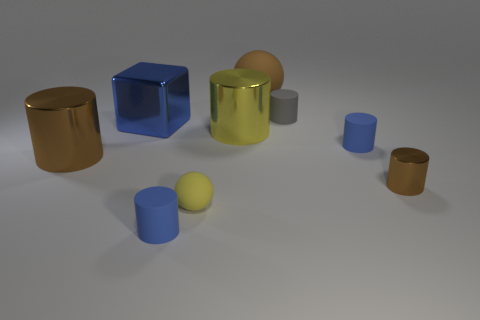What is the big brown thing on the left side of the big yellow object made of?
Provide a succinct answer. Metal. There is a block that is the same material as the large yellow thing; what color is it?
Provide a short and direct response. Blue. What number of rubber objects are blue blocks or tiny brown cylinders?
Keep it short and to the point. 0. What is the shape of the yellow shiny thing that is the same size as the blue shiny thing?
Keep it short and to the point. Cylinder. What number of objects are tiny blue rubber cylinders that are right of the brown ball or tiny matte cylinders behind the big blue cube?
Your response must be concise. 2. What is the material of the blue cube that is the same size as the yellow cylinder?
Make the answer very short. Metal. How many other things are there of the same material as the gray cylinder?
Offer a terse response. 4. Are there the same number of objects that are to the left of the shiny block and large matte objects right of the gray object?
Give a very brief answer. No. What number of brown objects are small matte objects or rubber cylinders?
Offer a terse response. 0. There is a small ball; is it the same color as the big metallic thing on the right side of the big blue object?
Provide a short and direct response. Yes. 